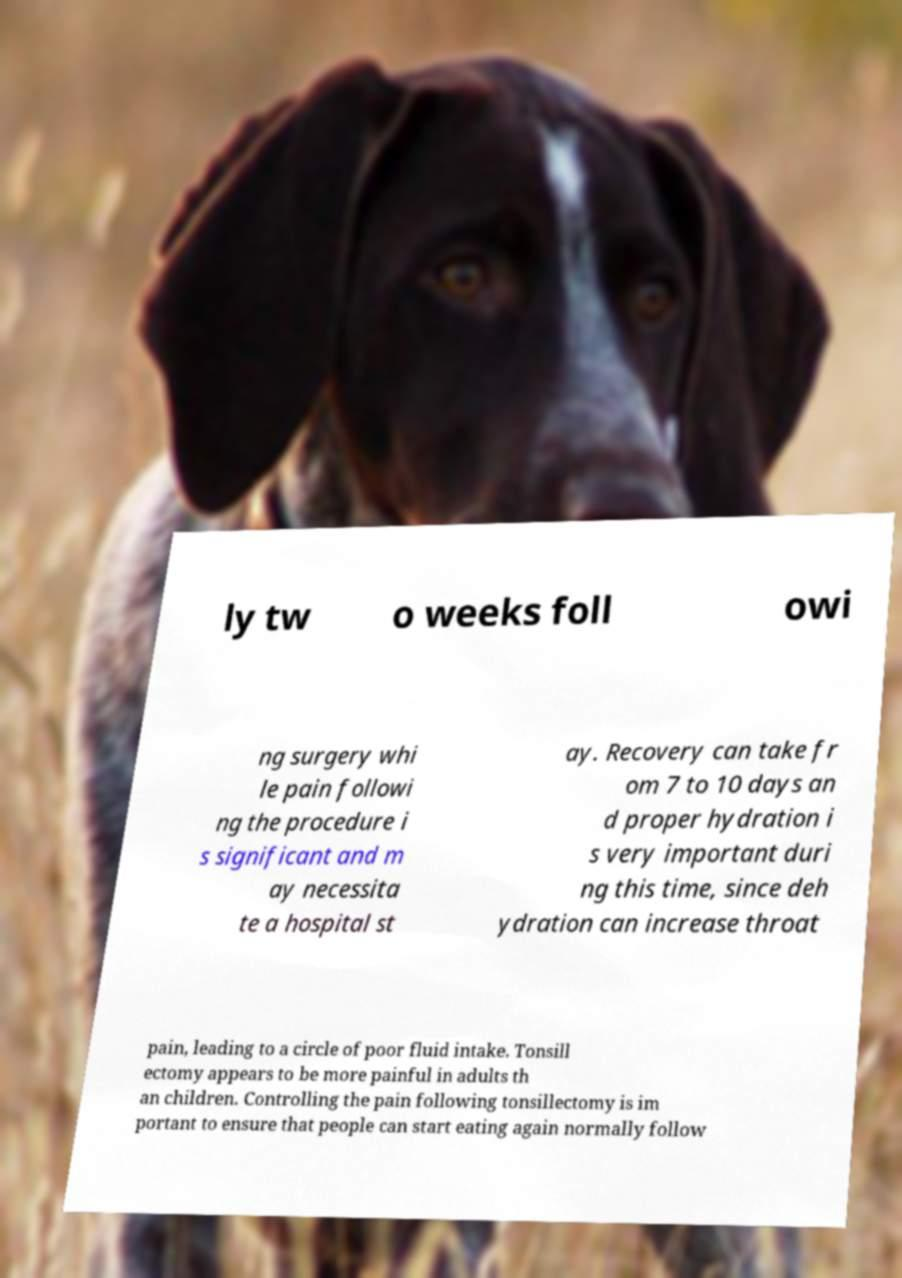Could you extract and type out the text from this image? ly tw o weeks foll owi ng surgery whi le pain followi ng the procedure i s significant and m ay necessita te a hospital st ay. Recovery can take fr om 7 to 10 days an d proper hydration i s very important duri ng this time, since deh ydration can increase throat pain, leading to a circle of poor fluid intake. Tonsill ectomy appears to be more painful in adults th an children. Controlling the pain following tonsillectomy is im portant to ensure that people can start eating again normally follow 